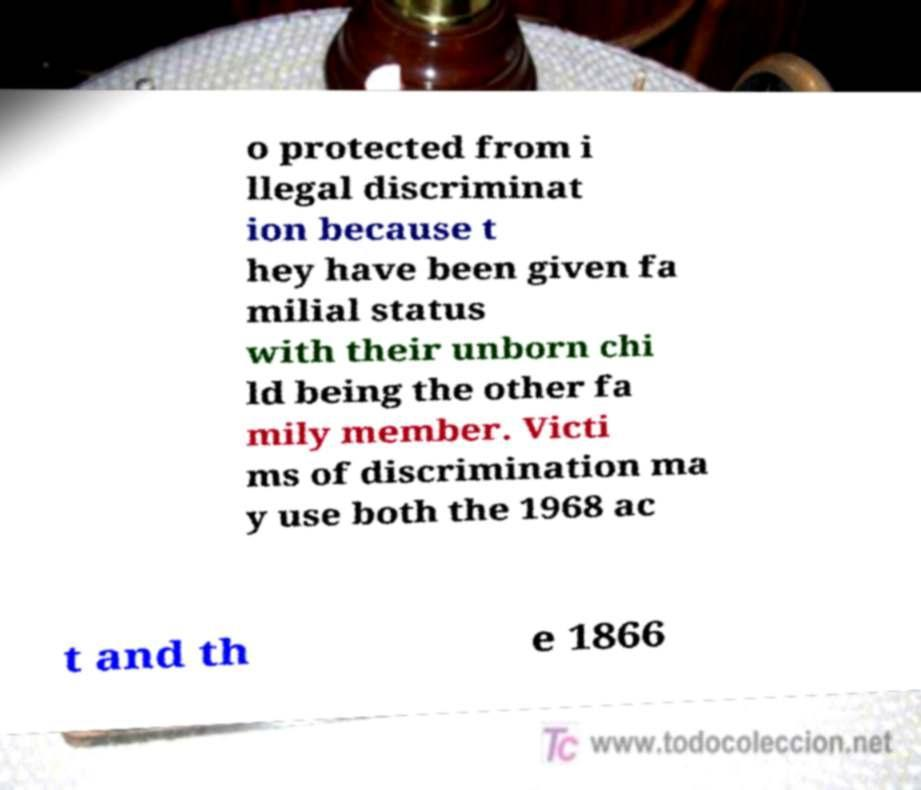There's text embedded in this image that I need extracted. Can you transcribe it verbatim? o protected from i llegal discriminat ion because t hey have been given fa milial status with their unborn chi ld being the other fa mily member. Victi ms of discrimination ma y use both the 1968 ac t and th e 1866 